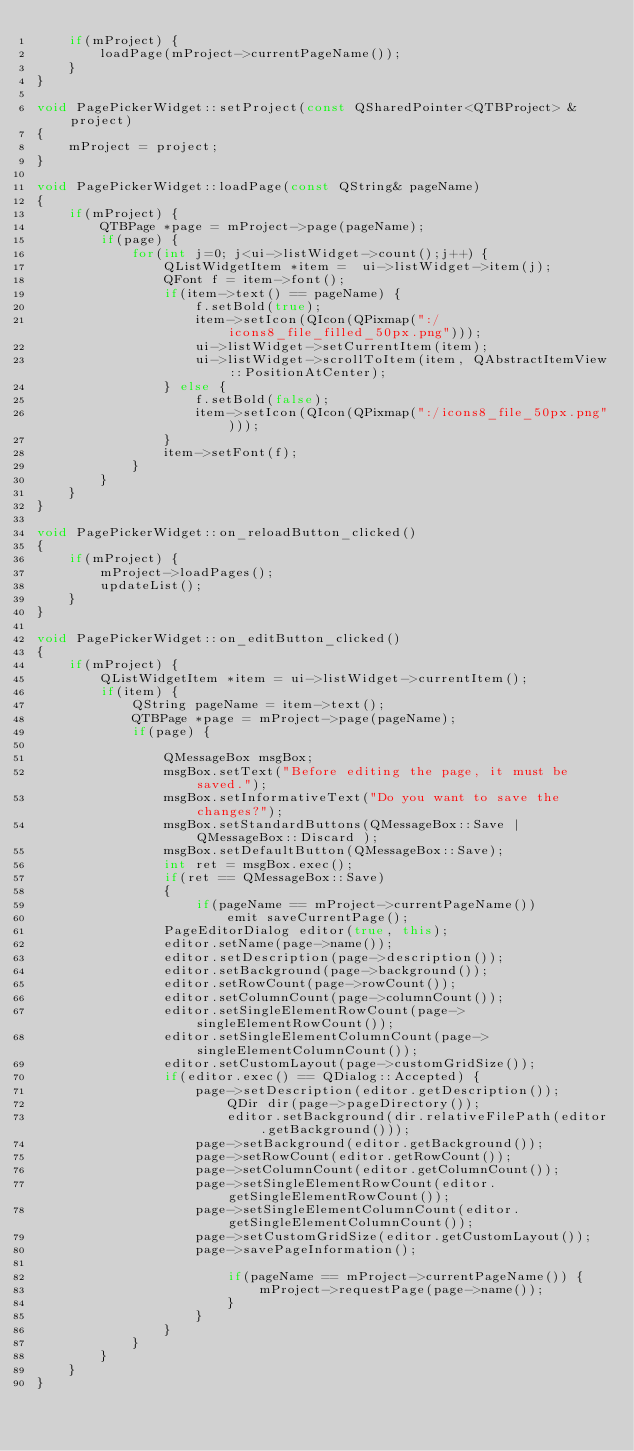<code> <loc_0><loc_0><loc_500><loc_500><_C++_>    if(mProject) {
        loadPage(mProject->currentPageName());
    }
}

void PagePickerWidget::setProject(const QSharedPointer<QTBProject> &project)
{
    mProject = project;
}

void PagePickerWidget::loadPage(const QString& pageName)
{
    if(mProject) {
        QTBPage *page = mProject->page(pageName);
        if(page) {
            for(int j=0; j<ui->listWidget->count();j++) {
                QListWidgetItem *item =  ui->listWidget->item(j);
                QFont f = item->font();
                if(item->text() == pageName) {
                    f.setBold(true);
                    item->setIcon(QIcon(QPixmap(":/icons8_file_filled_50px.png")));
                    ui->listWidget->setCurrentItem(item);
                    ui->listWidget->scrollToItem(item, QAbstractItemView::PositionAtCenter);
                } else {
                    f.setBold(false);
                    item->setIcon(QIcon(QPixmap(":/icons8_file_50px.png")));
                }
                item->setFont(f);
            }
        }
    }
}

void PagePickerWidget::on_reloadButton_clicked()
{
    if(mProject) {
        mProject->loadPages();
        updateList();
    }
}

void PagePickerWidget::on_editButton_clicked()
{
    if(mProject) {
        QListWidgetItem *item = ui->listWidget->currentItem();
        if(item) {
            QString pageName = item->text();
            QTBPage *page = mProject->page(pageName);
            if(page) {

                QMessageBox msgBox;
                msgBox.setText("Before editing the page, it must be saved.");
                msgBox.setInformativeText("Do you want to save the changes?");
                msgBox.setStandardButtons(QMessageBox::Save | QMessageBox::Discard );
                msgBox.setDefaultButton(QMessageBox::Save);
                int ret = msgBox.exec();
                if(ret == QMessageBox::Save)
                {
                    if(pageName == mProject->currentPageName())
                        emit saveCurrentPage();
                PageEditorDialog editor(true, this);
                editor.setName(page->name());
                editor.setDescription(page->description());
                editor.setBackground(page->background());
                editor.setRowCount(page->rowCount());
                editor.setColumnCount(page->columnCount());
                editor.setSingleElementRowCount(page->singleElementRowCount());
                editor.setSingleElementColumnCount(page->singleElementColumnCount());
                editor.setCustomLayout(page->customGridSize());
                if(editor.exec() == QDialog::Accepted) {
                    page->setDescription(editor.getDescription());
                        QDir dir(page->pageDirectory());
                        editor.setBackground(dir.relativeFilePath(editor.getBackground()));
                    page->setBackground(editor.getBackground());
                    page->setRowCount(editor.getRowCount());
                    page->setColumnCount(editor.getColumnCount());
                    page->setSingleElementRowCount(editor.getSingleElementRowCount());
                    page->setSingleElementColumnCount(editor.getSingleElementColumnCount());
                    page->setCustomGridSize(editor.getCustomLayout());
                    page->savePageInformation();

                        if(pageName == mProject->currentPageName()) {
                            mProject->requestPage(page->name());
                        }
                    }
                }
            }
        }
    }
}
</code> 